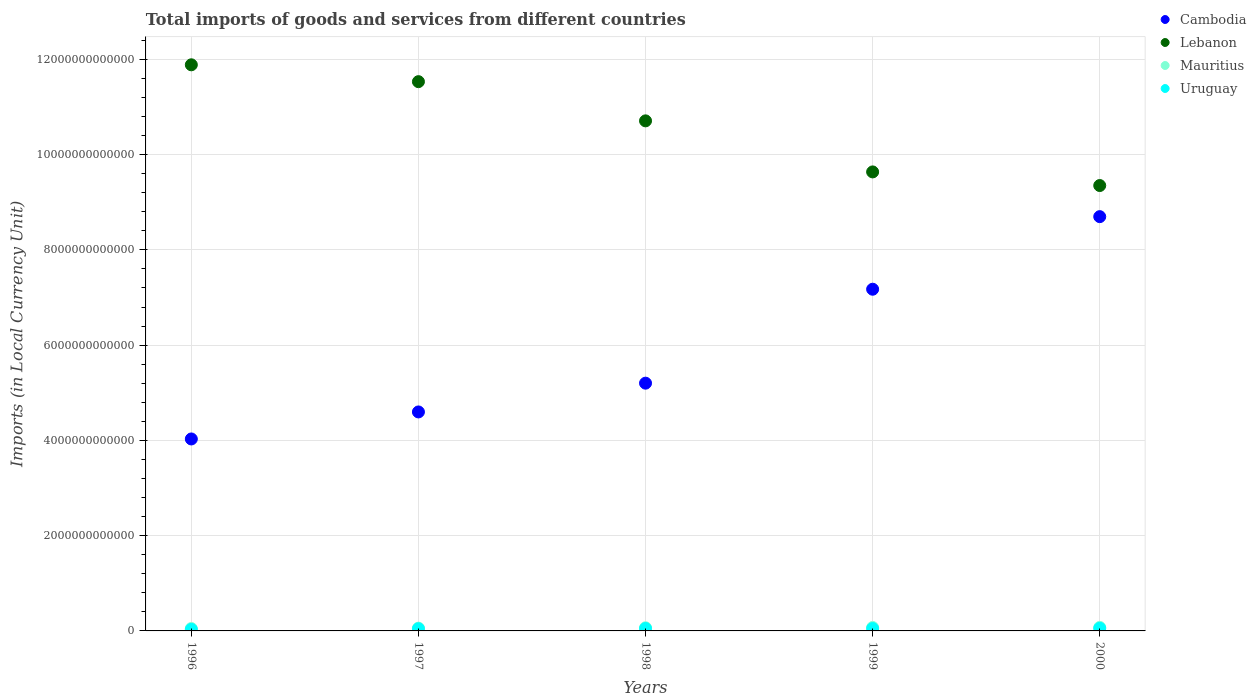How many different coloured dotlines are there?
Ensure brevity in your answer.  4. What is the Amount of goods and services imports in Lebanon in 1998?
Give a very brief answer. 1.07e+13. Across all years, what is the maximum Amount of goods and services imports in Uruguay?
Your answer should be compact. 5.53e+1. Across all years, what is the minimum Amount of goods and services imports in Cambodia?
Give a very brief answer. 4.03e+12. What is the total Amount of goods and services imports in Mauritius in the graph?
Give a very brief answer. 3.23e+11. What is the difference between the Amount of goods and services imports in Mauritius in 1997 and that in 1999?
Offer a very short reply. -1.44e+1. What is the difference between the Amount of goods and services imports in Mauritius in 1998 and the Amount of goods and services imports in Lebanon in 1997?
Offer a very short reply. -1.15e+13. What is the average Amount of goods and services imports in Cambodia per year?
Ensure brevity in your answer.  5.94e+12. In the year 2000, what is the difference between the Amount of goods and services imports in Lebanon and Amount of goods and services imports in Mauritius?
Keep it short and to the point. 9.28e+12. In how many years, is the Amount of goods and services imports in Cambodia greater than 9600000000000 LCU?
Offer a terse response. 0. What is the ratio of the Amount of goods and services imports in Lebanon in 1997 to that in 2000?
Offer a very short reply. 1.23. Is the difference between the Amount of goods and services imports in Lebanon in 1997 and 1998 greater than the difference between the Amount of goods and services imports in Mauritius in 1997 and 1998?
Your response must be concise. Yes. What is the difference between the highest and the second highest Amount of goods and services imports in Uruguay?
Your answer should be compact. 4.18e+09. What is the difference between the highest and the lowest Amount of goods and services imports in Lebanon?
Give a very brief answer. 2.53e+12. In how many years, is the Amount of goods and services imports in Uruguay greater than the average Amount of goods and services imports in Uruguay taken over all years?
Give a very brief answer. 3. How many dotlines are there?
Your response must be concise. 4. How many years are there in the graph?
Ensure brevity in your answer.  5. What is the difference between two consecutive major ticks on the Y-axis?
Provide a short and direct response. 2.00e+12. Are the values on the major ticks of Y-axis written in scientific E-notation?
Give a very brief answer. No. Does the graph contain any zero values?
Your response must be concise. No. Does the graph contain grids?
Offer a terse response. Yes. Where does the legend appear in the graph?
Offer a terse response. Top right. What is the title of the graph?
Your response must be concise. Total imports of goods and services from different countries. Does "Bosnia and Herzegovina" appear as one of the legend labels in the graph?
Offer a very short reply. No. What is the label or title of the X-axis?
Provide a short and direct response. Years. What is the label or title of the Y-axis?
Provide a short and direct response. Imports (in Local Currency Unit). What is the Imports (in Local Currency Unit) in Cambodia in 1996?
Offer a terse response. 4.03e+12. What is the Imports (in Local Currency Unit) in Lebanon in 1996?
Provide a short and direct response. 1.19e+13. What is the Imports (in Local Currency Unit) of Mauritius in 1996?
Give a very brief answer. 5.10e+1. What is the Imports (in Local Currency Unit) in Uruguay in 1996?
Provide a succinct answer. 3.25e+1. What is the Imports (in Local Currency Unit) of Cambodia in 1997?
Provide a short and direct response. 4.60e+12. What is the Imports (in Local Currency Unit) of Lebanon in 1997?
Give a very brief answer. 1.15e+13. What is the Imports (in Local Currency Unit) in Mauritius in 1997?
Offer a terse response. 5.85e+1. What is the Imports (in Local Currency Unit) in Uruguay in 1997?
Your answer should be compact. 4.58e+1. What is the Imports (in Local Currency Unit) of Cambodia in 1998?
Your response must be concise. 5.20e+12. What is the Imports (in Local Currency Unit) of Lebanon in 1998?
Ensure brevity in your answer.  1.07e+13. What is the Imports (in Local Currency Unit) of Mauritius in 1998?
Offer a very short reply. 6.65e+1. What is the Imports (in Local Currency Unit) of Uruguay in 1998?
Provide a short and direct response. 5.11e+1. What is the Imports (in Local Currency Unit) in Cambodia in 1999?
Keep it short and to the point. 7.17e+12. What is the Imports (in Local Currency Unit) of Lebanon in 1999?
Your response must be concise. 9.64e+12. What is the Imports (in Local Currency Unit) of Mauritius in 1999?
Provide a short and direct response. 7.29e+1. What is the Imports (in Local Currency Unit) in Uruguay in 1999?
Provide a succinct answer. 4.97e+1. What is the Imports (in Local Currency Unit) of Cambodia in 2000?
Provide a short and direct response. 8.70e+12. What is the Imports (in Local Currency Unit) in Lebanon in 2000?
Provide a short and direct response. 9.35e+12. What is the Imports (in Local Currency Unit) in Mauritius in 2000?
Your response must be concise. 7.45e+1. What is the Imports (in Local Currency Unit) in Uruguay in 2000?
Your answer should be compact. 5.53e+1. Across all years, what is the maximum Imports (in Local Currency Unit) in Cambodia?
Provide a short and direct response. 8.70e+12. Across all years, what is the maximum Imports (in Local Currency Unit) of Lebanon?
Offer a terse response. 1.19e+13. Across all years, what is the maximum Imports (in Local Currency Unit) of Mauritius?
Your response must be concise. 7.45e+1. Across all years, what is the maximum Imports (in Local Currency Unit) in Uruguay?
Your answer should be compact. 5.53e+1. Across all years, what is the minimum Imports (in Local Currency Unit) of Cambodia?
Your response must be concise. 4.03e+12. Across all years, what is the minimum Imports (in Local Currency Unit) of Lebanon?
Make the answer very short. 9.35e+12. Across all years, what is the minimum Imports (in Local Currency Unit) of Mauritius?
Offer a very short reply. 5.10e+1. Across all years, what is the minimum Imports (in Local Currency Unit) in Uruguay?
Provide a short and direct response. 3.25e+1. What is the total Imports (in Local Currency Unit) of Cambodia in the graph?
Your answer should be compact. 2.97e+13. What is the total Imports (in Local Currency Unit) of Lebanon in the graph?
Your answer should be very brief. 5.31e+13. What is the total Imports (in Local Currency Unit) of Mauritius in the graph?
Provide a short and direct response. 3.23e+11. What is the total Imports (in Local Currency Unit) in Uruguay in the graph?
Provide a short and direct response. 2.34e+11. What is the difference between the Imports (in Local Currency Unit) of Cambodia in 1996 and that in 1997?
Make the answer very short. -5.67e+11. What is the difference between the Imports (in Local Currency Unit) of Lebanon in 1996 and that in 1997?
Offer a very short reply. 3.54e+11. What is the difference between the Imports (in Local Currency Unit) of Mauritius in 1996 and that in 1997?
Provide a short and direct response. -7.49e+09. What is the difference between the Imports (in Local Currency Unit) of Uruguay in 1996 and that in 1997?
Keep it short and to the point. -1.33e+1. What is the difference between the Imports (in Local Currency Unit) in Cambodia in 1996 and that in 1998?
Provide a succinct answer. -1.17e+12. What is the difference between the Imports (in Local Currency Unit) in Lebanon in 1996 and that in 1998?
Provide a short and direct response. 1.18e+12. What is the difference between the Imports (in Local Currency Unit) in Mauritius in 1996 and that in 1998?
Offer a terse response. -1.55e+1. What is the difference between the Imports (in Local Currency Unit) of Uruguay in 1996 and that in 1998?
Make the answer very short. -1.86e+1. What is the difference between the Imports (in Local Currency Unit) in Cambodia in 1996 and that in 1999?
Provide a short and direct response. -3.14e+12. What is the difference between the Imports (in Local Currency Unit) of Lebanon in 1996 and that in 1999?
Provide a succinct answer. 2.25e+12. What is the difference between the Imports (in Local Currency Unit) in Mauritius in 1996 and that in 1999?
Give a very brief answer. -2.19e+1. What is the difference between the Imports (in Local Currency Unit) of Uruguay in 1996 and that in 1999?
Give a very brief answer. -1.73e+1. What is the difference between the Imports (in Local Currency Unit) of Cambodia in 1996 and that in 2000?
Offer a terse response. -4.67e+12. What is the difference between the Imports (in Local Currency Unit) of Lebanon in 1996 and that in 2000?
Provide a short and direct response. 2.53e+12. What is the difference between the Imports (in Local Currency Unit) in Mauritius in 1996 and that in 2000?
Keep it short and to the point. -2.35e+1. What is the difference between the Imports (in Local Currency Unit) of Uruguay in 1996 and that in 2000?
Make the answer very short. -2.28e+1. What is the difference between the Imports (in Local Currency Unit) in Cambodia in 1997 and that in 1998?
Provide a short and direct response. -6.04e+11. What is the difference between the Imports (in Local Currency Unit) of Lebanon in 1997 and that in 1998?
Provide a succinct answer. 8.23e+11. What is the difference between the Imports (in Local Currency Unit) in Mauritius in 1997 and that in 1998?
Offer a very short reply. -8.04e+09. What is the difference between the Imports (in Local Currency Unit) of Uruguay in 1997 and that in 1998?
Keep it short and to the point. -5.27e+09. What is the difference between the Imports (in Local Currency Unit) in Cambodia in 1997 and that in 1999?
Give a very brief answer. -2.58e+12. What is the difference between the Imports (in Local Currency Unit) of Lebanon in 1997 and that in 1999?
Keep it short and to the point. 1.90e+12. What is the difference between the Imports (in Local Currency Unit) in Mauritius in 1997 and that in 1999?
Your answer should be compact. -1.44e+1. What is the difference between the Imports (in Local Currency Unit) of Uruguay in 1997 and that in 1999?
Provide a succinct answer. -3.91e+09. What is the difference between the Imports (in Local Currency Unit) of Cambodia in 1997 and that in 2000?
Offer a terse response. -4.10e+12. What is the difference between the Imports (in Local Currency Unit) in Lebanon in 1997 and that in 2000?
Keep it short and to the point. 2.18e+12. What is the difference between the Imports (in Local Currency Unit) in Mauritius in 1997 and that in 2000?
Provide a short and direct response. -1.60e+1. What is the difference between the Imports (in Local Currency Unit) in Uruguay in 1997 and that in 2000?
Keep it short and to the point. -9.45e+09. What is the difference between the Imports (in Local Currency Unit) of Cambodia in 1998 and that in 1999?
Your response must be concise. -1.97e+12. What is the difference between the Imports (in Local Currency Unit) in Lebanon in 1998 and that in 1999?
Your response must be concise. 1.07e+12. What is the difference between the Imports (in Local Currency Unit) of Mauritius in 1998 and that in 1999?
Offer a very short reply. -6.32e+09. What is the difference between the Imports (in Local Currency Unit) in Uruguay in 1998 and that in 1999?
Offer a very short reply. 1.36e+09. What is the difference between the Imports (in Local Currency Unit) in Cambodia in 1998 and that in 2000?
Give a very brief answer. -3.50e+12. What is the difference between the Imports (in Local Currency Unit) in Lebanon in 1998 and that in 2000?
Offer a very short reply. 1.36e+12. What is the difference between the Imports (in Local Currency Unit) of Mauritius in 1998 and that in 2000?
Your answer should be compact. -7.97e+09. What is the difference between the Imports (in Local Currency Unit) of Uruguay in 1998 and that in 2000?
Offer a very short reply. -4.18e+09. What is the difference between the Imports (in Local Currency Unit) of Cambodia in 1999 and that in 2000?
Offer a terse response. -1.52e+12. What is the difference between the Imports (in Local Currency Unit) in Lebanon in 1999 and that in 2000?
Provide a short and direct response. 2.86e+11. What is the difference between the Imports (in Local Currency Unit) in Mauritius in 1999 and that in 2000?
Keep it short and to the point. -1.65e+09. What is the difference between the Imports (in Local Currency Unit) of Uruguay in 1999 and that in 2000?
Offer a terse response. -5.54e+09. What is the difference between the Imports (in Local Currency Unit) in Cambodia in 1996 and the Imports (in Local Currency Unit) in Lebanon in 1997?
Offer a terse response. -7.50e+12. What is the difference between the Imports (in Local Currency Unit) in Cambodia in 1996 and the Imports (in Local Currency Unit) in Mauritius in 1997?
Provide a succinct answer. 3.97e+12. What is the difference between the Imports (in Local Currency Unit) in Cambodia in 1996 and the Imports (in Local Currency Unit) in Uruguay in 1997?
Your response must be concise. 3.98e+12. What is the difference between the Imports (in Local Currency Unit) in Lebanon in 1996 and the Imports (in Local Currency Unit) in Mauritius in 1997?
Provide a succinct answer. 1.18e+13. What is the difference between the Imports (in Local Currency Unit) of Lebanon in 1996 and the Imports (in Local Currency Unit) of Uruguay in 1997?
Provide a short and direct response. 1.18e+13. What is the difference between the Imports (in Local Currency Unit) in Mauritius in 1996 and the Imports (in Local Currency Unit) in Uruguay in 1997?
Your response must be concise. 5.18e+09. What is the difference between the Imports (in Local Currency Unit) in Cambodia in 1996 and the Imports (in Local Currency Unit) in Lebanon in 1998?
Your answer should be compact. -6.68e+12. What is the difference between the Imports (in Local Currency Unit) in Cambodia in 1996 and the Imports (in Local Currency Unit) in Mauritius in 1998?
Your answer should be compact. 3.96e+12. What is the difference between the Imports (in Local Currency Unit) in Cambodia in 1996 and the Imports (in Local Currency Unit) in Uruguay in 1998?
Your answer should be compact. 3.98e+12. What is the difference between the Imports (in Local Currency Unit) of Lebanon in 1996 and the Imports (in Local Currency Unit) of Mauritius in 1998?
Provide a short and direct response. 1.18e+13. What is the difference between the Imports (in Local Currency Unit) in Lebanon in 1996 and the Imports (in Local Currency Unit) in Uruguay in 1998?
Keep it short and to the point. 1.18e+13. What is the difference between the Imports (in Local Currency Unit) of Mauritius in 1996 and the Imports (in Local Currency Unit) of Uruguay in 1998?
Offer a terse response. -8.45e+07. What is the difference between the Imports (in Local Currency Unit) in Cambodia in 1996 and the Imports (in Local Currency Unit) in Lebanon in 1999?
Keep it short and to the point. -5.61e+12. What is the difference between the Imports (in Local Currency Unit) in Cambodia in 1996 and the Imports (in Local Currency Unit) in Mauritius in 1999?
Provide a succinct answer. 3.96e+12. What is the difference between the Imports (in Local Currency Unit) in Cambodia in 1996 and the Imports (in Local Currency Unit) in Uruguay in 1999?
Your response must be concise. 3.98e+12. What is the difference between the Imports (in Local Currency Unit) in Lebanon in 1996 and the Imports (in Local Currency Unit) in Mauritius in 1999?
Offer a very short reply. 1.18e+13. What is the difference between the Imports (in Local Currency Unit) in Lebanon in 1996 and the Imports (in Local Currency Unit) in Uruguay in 1999?
Ensure brevity in your answer.  1.18e+13. What is the difference between the Imports (in Local Currency Unit) in Mauritius in 1996 and the Imports (in Local Currency Unit) in Uruguay in 1999?
Offer a very short reply. 1.27e+09. What is the difference between the Imports (in Local Currency Unit) of Cambodia in 1996 and the Imports (in Local Currency Unit) of Lebanon in 2000?
Your answer should be very brief. -5.32e+12. What is the difference between the Imports (in Local Currency Unit) in Cambodia in 1996 and the Imports (in Local Currency Unit) in Mauritius in 2000?
Provide a succinct answer. 3.96e+12. What is the difference between the Imports (in Local Currency Unit) in Cambodia in 1996 and the Imports (in Local Currency Unit) in Uruguay in 2000?
Your response must be concise. 3.97e+12. What is the difference between the Imports (in Local Currency Unit) in Lebanon in 1996 and the Imports (in Local Currency Unit) in Mauritius in 2000?
Give a very brief answer. 1.18e+13. What is the difference between the Imports (in Local Currency Unit) in Lebanon in 1996 and the Imports (in Local Currency Unit) in Uruguay in 2000?
Provide a short and direct response. 1.18e+13. What is the difference between the Imports (in Local Currency Unit) in Mauritius in 1996 and the Imports (in Local Currency Unit) in Uruguay in 2000?
Keep it short and to the point. -4.26e+09. What is the difference between the Imports (in Local Currency Unit) of Cambodia in 1997 and the Imports (in Local Currency Unit) of Lebanon in 1998?
Offer a very short reply. -6.11e+12. What is the difference between the Imports (in Local Currency Unit) of Cambodia in 1997 and the Imports (in Local Currency Unit) of Mauritius in 1998?
Ensure brevity in your answer.  4.53e+12. What is the difference between the Imports (in Local Currency Unit) in Cambodia in 1997 and the Imports (in Local Currency Unit) in Uruguay in 1998?
Your answer should be very brief. 4.55e+12. What is the difference between the Imports (in Local Currency Unit) of Lebanon in 1997 and the Imports (in Local Currency Unit) of Mauritius in 1998?
Your answer should be compact. 1.15e+13. What is the difference between the Imports (in Local Currency Unit) in Lebanon in 1997 and the Imports (in Local Currency Unit) in Uruguay in 1998?
Offer a terse response. 1.15e+13. What is the difference between the Imports (in Local Currency Unit) in Mauritius in 1997 and the Imports (in Local Currency Unit) in Uruguay in 1998?
Make the answer very short. 7.40e+09. What is the difference between the Imports (in Local Currency Unit) in Cambodia in 1997 and the Imports (in Local Currency Unit) in Lebanon in 1999?
Offer a very short reply. -5.04e+12. What is the difference between the Imports (in Local Currency Unit) of Cambodia in 1997 and the Imports (in Local Currency Unit) of Mauritius in 1999?
Keep it short and to the point. 4.52e+12. What is the difference between the Imports (in Local Currency Unit) of Cambodia in 1997 and the Imports (in Local Currency Unit) of Uruguay in 1999?
Keep it short and to the point. 4.55e+12. What is the difference between the Imports (in Local Currency Unit) in Lebanon in 1997 and the Imports (in Local Currency Unit) in Mauritius in 1999?
Ensure brevity in your answer.  1.15e+13. What is the difference between the Imports (in Local Currency Unit) of Lebanon in 1997 and the Imports (in Local Currency Unit) of Uruguay in 1999?
Keep it short and to the point. 1.15e+13. What is the difference between the Imports (in Local Currency Unit) in Mauritius in 1997 and the Imports (in Local Currency Unit) in Uruguay in 1999?
Offer a very short reply. 8.76e+09. What is the difference between the Imports (in Local Currency Unit) of Cambodia in 1997 and the Imports (in Local Currency Unit) of Lebanon in 2000?
Your answer should be compact. -4.75e+12. What is the difference between the Imports (in Local Currency Unit) of Cambodia in 1997 and the Imports (in Local Currency Unit) of Mauritius in 2000?
Give a very brief answer. 4.52e+12. What is the difference between the Imports (in Local Currency Unit) of Cambodia in 1997 and the Imports (in Local Currency Unit) of Uruguay in 2000?
Make the answer very short. 4.54e+12. What is the difference between the Imports (in Local Currency Unit) in Lebanon in 1997 and the Imports (in Local Currency Unit) in Mauritius in 2000?
Offer a very short reply. 1.15e+13. What is the difference between the Imports (in Local Currency Unit) of Lebanon in 1997 and the Imports (in Local Currency Unit) of Uruguay in 2000?
Offer a very short reply. 1.15e+13. What is the difference between the Imports (in Local Currency Unit) of Mauritius in 1997 and the Imports (in Local Currency Unit) of Uruguay in 2000?
Your response must be concise. 3.22e+09. What is the difference between the Imports (in Local Currency Unit) of Cambodia in 1998 and the Imports (in Local Currency Unit) of Lebanon in 1999?
Your response must be concise. -4.44e+12. What is the difference between the Imports (in Local Currency Unit) of Cambodia in 1998 and the Imports (in Local Currency Unit) of Mauritius in 1999?
Keep it short and to the point. 5.13e+12. What is the difference between the Imports (in Local Currency Unit) of Cambodia in 1998 and the Imports (in Local Currency Unit) of Uruguay in 1999?
Your answer should be compact. 5.15e+12. What is the difference between the Imports (in Local Currency Unit) in Lebanon in 1998 and the Imports (in Local Currency Unit) in Mauritius in 1999?
Provide a short and direct response. 1.06e+13. What is the difference between the Imports (in Local Currency Unit) in Lebanon in 1998 and the Imports (in Local Currency Unit) in Uruguay in 1999?
Your answer should be very brief. 1.07e+13. What is the difference between the Imports (in Local Currency Unit) of Mauritius in 1998 and the Imports (in Local Currency Unit) of Uruguay in 1999?
Provide a short and direct response. 1.68e+1. What is the difference between the Imports (in Local Currency Unit) of Cambodia in 1998 and the Imports (in Local Currency Unit) of Lebanon in 2000?
Make the answer very short. -4.15e+12. What is the difference between the Imports (in Local Currency Unit) of Cambodia in 1998 and the Imports (in Local Currency Unit) of Mauritius in 2000?
Make the answer very short. 5.13e+12. What is the difference between the Imports (in Local Currency Unit) of Cambodia in 1998 and the Imports (in Local Currency Unit) of Uruguay in 2000?
Ensure brevity in your answer.  5.15e+12. What is the difference between the Imports (in Local Currency Unit) in Lebanon in 1998 and the Imports (in Local Currency Unit) in Mauritius in 2000?
Your answer should be compact. 1.06e+13. What is the difference between the Imports (in Local Currency Unit) of Lebanon in 1998 and the Imports (in Local Currency Unit) of Uruguay in 2000?
Provide a short and direct response. 1.07e+13. What is the difference between the Imports (in Local Currency Unit) in Mauritius in 1998 and the Imports (in Local Currency Unit) in Uruguay in 2000?
Make the answer very short. 1.13e+1. What is the difference between the Imports (in Local Currency Unit) in Cambodia in 1999 and the Imports (in Local Currency Unit) in Lebanon in 2000?
Offer a terse response. -2.18e+12. What is the difference between the Imports (in Local Currency Unit) of Cambodia in 1999 and the Imports (in Local Currency Unit) of Mauritius in 2000?
Keep it short and to the point. 7.10e+12. What is the difference between the Imports (in Local Currency Unit) in Cambodia in 1999 and the Imports (in Local Currency Unit) in Uruguay in 2000?
Your response must be concise. 7.12e+12. What is the difference between the Imports (in Local Currency Unit) of Lebanon in 1999 and the Imports (in Local Currency Unit) of Mauritius in 2000?
Give a very brief answer. 9.56e+12. What is the difference between the Imports (in Local Currency Unit) in Lebanon in 1999 and the Imports (in Local Currency Unit) in Uruguay in 2000?
Keep it short and to the point. 9.58e+12. What is the difference between the Imports (in Local Currency Unit) of Mauritius in 1999 and the Imports (in Local Currency Unit) of Uruguay in 2000?
Give a very brief answer. 1.76e+1. What is the average Imports (in Local Currency Unit) of Cambodia per year?
Offer a terse response. 5.94e+12. What is the average Imports (in Local Currency Unit) in Lebanon per year?
Your response must be concise. 1.06e+13. What is the average Imports (in Local Currency Unit) of Mauritius per year?
Your answer should be very brief. 6.47e+1. What is the average Imports (in Local Currency Unit) of Uruguay per year?
Ensure brevity in your answer.  4.69e+1. In the year 1996, what is the difference between the Imports (in Local Currency Unit) in Cambodia and Imports (in Local Currency Unit) in Lebanon?
Give a very brief answer. -7.86e+12. In the year 1996, what is the difference between the Imports (in Local Currency Unit) of Cambodia and Imports (in Local Currency Unit) of Mauritius?
Provide a short and direct response. 3.98e+12. In the year 1996, what is the difference between the Imports (in Local Currency Unit) in Cambodia and Imports (in Local Currency Unit) in Uruguay?
Ensure brevity in your answer.  4.00e+12. In the year 1996, what is the difference between the Imports (in Local Currency Unit) in Lebanon and Imports (in Local Currency Unit) in Mauritius?
Provide a succinct answer. 1.18e+13. In the year 1996, what is the difference between the Imports (in Local Currency Unit) of Lebanon and Imports (in Local Currency Unit) of Uruguay?
Provide a short and direct response. 1.19e+13. In the year 1996, what is the difference between the Imports (in Local Currency Unit) in Mauritius and Imports (in Local Currency Unit) in Uruguay?
Ensure brevity in your answer.  1.85e+1. In the year 1997, what is the difference between the Imports (in Local Currency Unit) in Cambodia and Imports (in Local Currency Unit) in Lebanon?
Offer a very short reply. -6.93e+12. In the year 1997, what is the difference between the Imports (in Local Currency Unit) in Cambodia and Imports (in Local Currency Unit) in Mauritius?
Ensure brevity in your answer.  4.54e+12. In the year 1997, what is the difference between the Imports (in Local Currency Unit) in Cambodia and Imports (in Local Currency Unit) in Uruguay?
Keep it short and to the point. 4.55e+12. In the year 1997, what is the difference between the Imports (in Local Currency Unit) of Lebanon and Imports (in Local Currency Unit) of Mauritius?
Your answer should be very brief. 1.15e+13. In the year 1997, what is the difference between the Imports (in Local Currency Unit) of Lebanon and Imports (in Local Currency Unit) of Uruguay?
Give a very brief answer. 1.15e+13. In the year 1997, what is the difference between the Imports (in Local Currency Unit) of Mauritius and Imports (in Local Currency Unit) of Uruguay?
Provide a short and direct response. 1.27e+1. In the year 1998, what is the difference between the Imports (in Local Currency Unit) in Cambodia and Imports (in Local Currency Unit) in Lebanon?
Your answer should be very brief. -5.51e+12. In the year 1998, what is the difference between the Imports (in Local Currency Unit) in Cambodia and Imports (in Local Currency Unit) in Mauritius?
Make the answer very short. 5.14e+12. In the year 1998, what is the difference between the Imports (in Local Currency Unit) of Cambodia and Imports (in Local Currency Unit) of Uruguay?
Provide a succinct answer. 5.15e+12. In the year 1998, what is the difference between the Imports (in Local Currency Unit) in Lebanon and Imports (in Local Currency Unit) in Mauritius?
Your response must be concise. 1.06e+13. In the year 1998, what is the difference between the Imports (in Local Currency Unit) of Lebanon and Imports (in Local Currency Unit) of Uruguay?
Offer a terse response. 1.07e+13. In the year 1998, what is the difference between the Imports (in Local Currency Unit) in Mauritius and Imports (in Local Currency Unit) in Uruguay?
Provide a short and direct response. 1.54e+1. In the year 1999, what is the difference between the Imports (in Local Currency Unit) in Cambodia and Imports (in Local Currency Unit) in Lebanon?
Your answer should be compact. -2.46e+12. In the year 1999, what is the difference between the Imports (in Local Currency Unit) of Cambodia and Imports (in Local Currency Unit) of Mauritius?
Your answer should be very brief. 7.10e+12. In the year 1999, what is the difference between the Imports (in Local Currency Unit) of Cambodia and Imports (in Local Currency Unit) of Uruguay?
Your response must be concise. 7.12e+12. In the year 1999, what is the difference between the Imports (in Local Currency Unit) of Lebanon and Imports (in Local Currency Unit) of Mauritius?
Offer a terse response. 9.56e+12. In the year 1999, what is the difference between the Imports (in Local Currency Unit) of Lebanon and Imports (in Local Currency Unit) of Uruguay?
Provide a succinct answer. 9.59e+12. In the year 1999, what is the difference between the Imports (in Local Currency Unit) of Mauritius and Imports (in Local Currency Unit) of Uruguay?
Offer a very short reply. 2.31e+1. In the year 2000, what is the difference between the Imports (in Local Currency Unit) of Cambodia and Imports (in Local Currency Unit) of Lebanon?
Your answer should be compact. -6.53e+11. In the year 2000, what is the difference between the Imports (in Local Currency Unit) of Cambodia and Imports (in Local Currency Unit) of Mauritius?
Your answer should be compact. 8.62e+12. In the year 2000, what is the difference between the Imports (in Local Currency Unit) of Cambodia and Imports (in Local Currency Unit) of Uruguay?
Your response must be concise. 8.64e+12. In the year 2000, what is the difference between the Imports (in Local Currency Unit) of Lebanon and Imports (in Local Currency Unit) of Mauritius?
Give a very brief answer. 9.28e+12. In the year 2000, what is the difference between the Imports (in Local Currency Unit) of Lebanon and Imports (in Local Currency Unit) of Uruguay?
Your answer should be compact. 9.30e+12. In the year 2000, what is the difference between the Imports (in Local Currency Unit) in Mauritius and Imports (in Local Currency Unit) in Uruguay?
Give a very brief answer. 1.92e+1. What is the ratio of the Imports (in Local Currency Unit) in Cambodia in 1996 to that in 1997?
Your answer should be very brief. 0.88. What is the ratio of the Imports (in Local Currency Unit) in Lebanon in 1996 to that in 1997?
Provide a short and direct response. 1.03. What is the ratio of the Imports (in Local Currency Unit) in Mauritius in 1996 to that in 1997?
Your answer should be compact. 0.87. What is the ratio of the Imports (in Local Currency Unit) in Uruguay in 1996 to that in 1997?
Ensure brevity in your answer.  0.71. What is the ratio of the Imports (in Local Currency Unit) in Cambodia in 1996 to that in 1998?
Your answer should be very brief. 0.77. What is the ratio of the Imports (in Local Currency Unit) in Lebanon in 1996 to that in 1998?
Your answer should be very brief. 1.11. What is the ratio of the Imports (in Local Currency Unit) in Mauritius in 1996 to that in 1998?
Provide a succinct answer. 0.77. What is the ratio of the Imports (in Local Currency Unit) in Uruguay in 1996 to that in 1998?
Ensure brevity in your answer.  0.64. What is the ratio of the Imports (in Local Currency Unit) in Cambodia in 1996 to that in 1999?
Offer a terse response. 0.56. What is the ratio of the Imports (in Local Currency Unit) in Lebanon in 1996 to that in 1999?
Offer a very short reply. 1.23. What is the ratio of the Imports (in Local Currency Unit) of Mauritius in 1996 to that in 1999?
Your answer should be compact. 0.7. What is the ratio of the Imports (in Local Currency Unit) in Uruguay in 1996 to that in 1999?
Provide a short and direct response. 0.65. What is the ratio of the Imports (in Local Currency Unit) of Cambodia in 1996 to that in 2000?
Offer a terse response. 0.46. What is the ratio of the Imports (in Local Currency Unit) in Lebanon in 1996 to that in 2000?
Offer a terse response. 1.27. What is the ratio of the Imports (in Local Currency Unit) of Mauritius in 1996 to that in 2000?
Provide a short and direct response. 0.68. What is the ratio of the Imports (in Local Currency Unit) in Uruguay in 1996 to that in 2000?
Offer a terse response. 0.59. What is the ratio of the Imports (in Local Currency Unit) of Cambodia in 1997 to that in 1998?
Make the answer very short. 0.88. What is the ratio of the Imports (in Local Currency Unit) in Mauritius in 1997 to that in 1998?
Your answer should be very brief. 0.88. What is the ratio of the Imports (in Local Currency Unit) of Uruguay in 1997 to that in 1998?
Give a very brief answer. 0.9. What is the ratio of the Imports (in Local Currency Unit) in Cambodia in 1997 to that in 1999?
Keep it short and to the point. 0.64. What is the ratio of the Imports (in Local Currency Unit) of Lebanon in 1997 to that in 1999?
Provide a short and direct response. 1.2. What is the ratio of the Imports (in Local Currency Unit) in Mauritius in 1997 to that in 1999?
Your answer should be very brief. 0.8. What is the ratio of the Imports (in Local Currency Unit) of Uruguay in 1997 to that in 1999?
Ensure brevity in your answer.  0.92. What is the ratio of the Imports (in Local Currency Unit) in Cambodia in 1997 to that in 2000?
Give a very brief answer. 0.53. What is the ratio of the Imports (in Local Currency Unit) of Lebanon in 1997 to that in 2000?
Provide a short and direct response. 1.23. What is the ratio of the Imports (in Local Currency Unit) in Mauritius in 1997 to that in 2000?
Your answer should be very brief. 0.79. What is the ratio of the Imports (in Local Currency Unit) in Uruguay in 1997 to that in 2000?
Give a very brief answer. 0.83. What is the ratio of the Imports (in Local Currency Unit) of Cambodia in 1998 to that in 1999?
Offer a very short reply. 0.73. What is the ratio of the Imports (in Local Currency Unit) of Lebanon in 1998 to that in 1999?
Provide a short and direct response. 1.11. What is the ratio of the Imports (in Local Currency Unit) of Mauritius in 1998 to that in 1999?
Your answer should be very brief. 0.91. What is the ratio of the Imports (in Local Currency Unit) in Uruguay in 1998 to that in 1999?
Offer a terse response. 1.03. What is the ratio of the Imports (in Local Currency Unit) of Cambodia in 1998 to that in 2000?
Offer a terse response. 0.6. What is the ratio of the Imports (in Local Currency Unit) of Lebanon in 1998 to that in 2000?
Give a very brief answer. 1.15. What is the ratio of the Imports (in Local Currency Unit) of Mauritius in 1998 to that in 2000?
Give a very brief answer. 0.89. What is the ratio of the Imports (in Local Currency Unit) of Uruguay in 1998 to that in 2000?
Your answer should be very brief. 0.92. What is the ratio of the Imports (in Local Currency Unit) in Cambodia in 1999 to that in 2000?
Offer a very short reply. 0.82. What is the ratio of the Imports (in Local Currency Unit) of Lebanon in 1999 to that in 2000?
Offer a very short reply. 1.03. What is the ratio of the Imports (in Local Currency Unit) in Mauritius in 1999 to that in 2000?
Your answer should be compact. 0.98. What is the ratio of the Imports (in Local Currency Unit) in Uruguay in 1999 to that in 2000?
Give a very brief answer. 0.9. What is the difference between the highest and the second highest Imports (in Local Currency Unit) in Cambodia?
Your answer should be compact. 1.52e+12. What is the difference between the highest and the second highest Imports (in Local Currency Unit) in Lebanon?
Give a very brief answer. 3.54e+11. What is the difference between the highest and the second highest Imports (in Local Currency Unit) of Mauritius?
Make the answer very short. 1.65e+09. What is the difference between the highest and the second highest Imports (in Local Currency Unit) of Uruguay?
Your answer should be very brief. 4.18e+09. What is the difference between the highest and the lowest Imports (in Local Currency Unit) in Cambodia?
Offer a terse response. 4.67e+12. What is the difference between the highest and the lowest Imports (in Local Currency Unit) of Lebanon?
Make the answer very short. 2.53e+12. What is the difference between the highest and the lowest Imports (in Local Currency Unit) in Mauritius?
Offer a very short reply. 2.35e+1. What is the difference between the highest and the lowest Imports (in Local Currency Unit) in Uruguay?
Keep it short and to the point. 2.28e+1. 